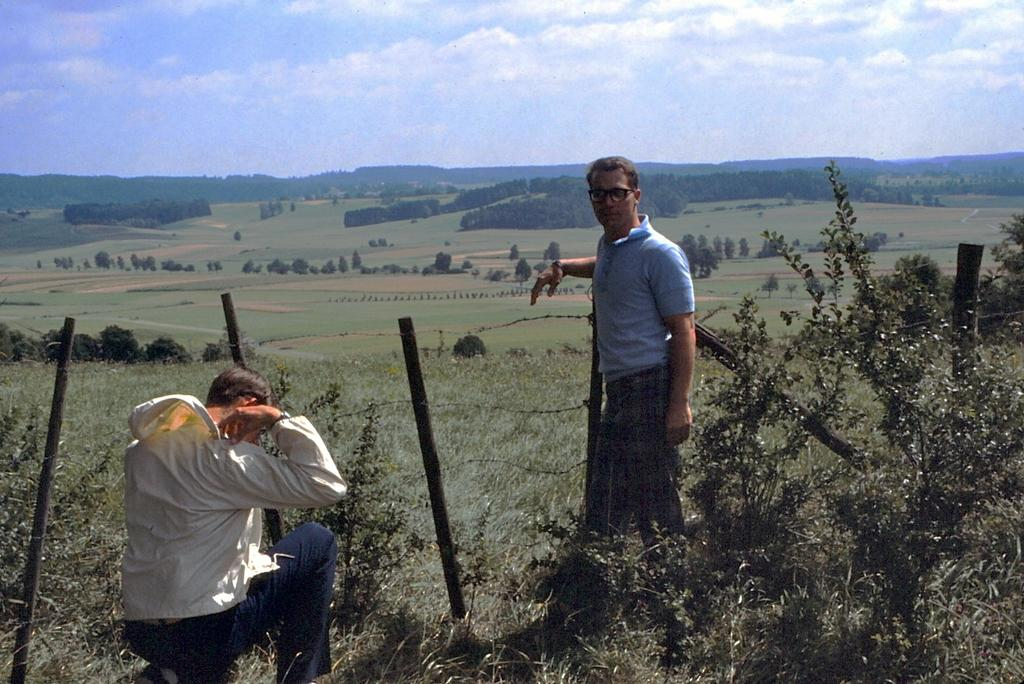How many people are present in the image? There are two persons in the image. What type of vegetation can be seen in the image? There are plants and trees in the image. What architectural feature is present in the image? There are poles with wire fence in the image. What natural feature can be seen in the image? There are hills in the image. What part of the natural environment is visible in the background of the image? The sky is visible in the background of the image. How much money is being exchanged between the two persons in the image? There is no indication of any money exchange in the image. What type of cave can be seen in the image? There is no cave present in the image. 